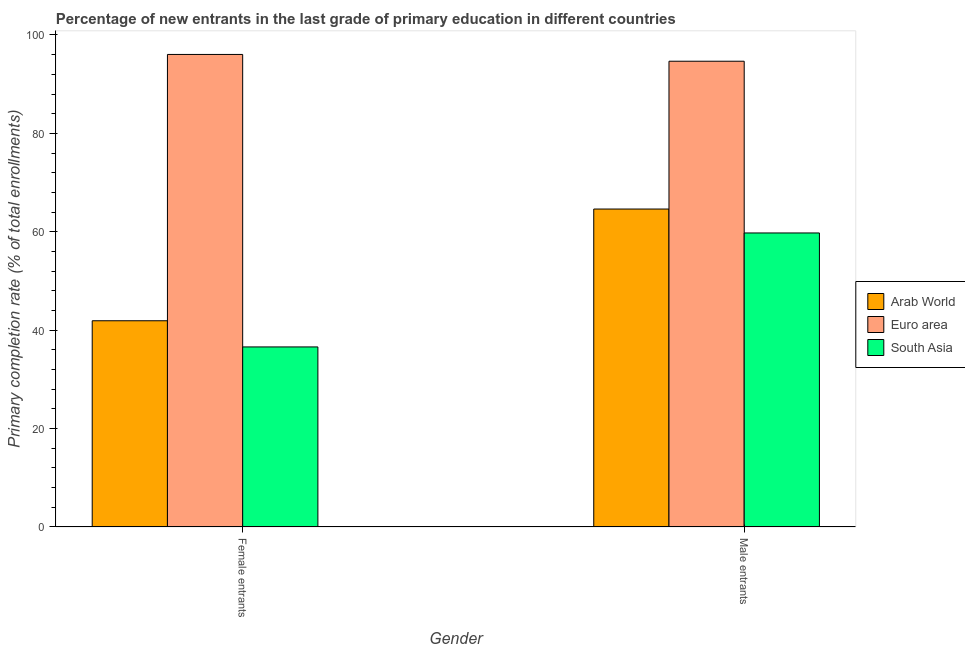How many different coloured bars are there?
Your answer should be compact. 3. Are the number of bars on each tick of the X-axis equal?
Offer a very short reply. Yes. How many bars are there on the 1st tick from the right?
Your response must be concise. 3. What is the label of the 2nd group of bars from the left?
Give a very brief answer. Male entrants. What is the primary completion rate of male entrants in South Asia?
Make the answer very short. 59.76. Across all countries, what is the maximum primary completion rate of male entrants?
Offer a very short reply. 94.66. Across all countries, what is the minimum primary completion rate of male entrants?
Provide a succinct answer. 59.76. What is the total primary completion rate of female entrants in the graph?
Make the answer very short. 174.55. What is the difference between the primary completion rate of male entrants in Arab World and that in South Asia?
Offer a very short reply. 4.86. What is the difference between the primary completion rate of male entrants in South Asia and the primary completion rate of female entrants in Euro area?
Offer a very short reply. -36.28. What is the average primary completion rate of male entrants per country?
Ensure brevity in your answer.  73.01. What is the difference between the primary completion rate of female entrants and primary completion rate of male entrants in South Asia?
Provide a succinct answer. -23.16. What is the ratio of the primary completion rate of female entrants in Arab World to that in South Asia?
Keep it short and to the point. 1.15. What does the 1st bar from the left in Male entrants represents?
Make the answer very short. Arab World. What does the 2nd bar from the right in Male entrants represents?
Keep it short and to the point. Euro area. How many countries are there in the graph?
Provide a short and direct response. 3. Does the graph contain any zero values?
Ensure brevity in your answer.  No. Does the graph contain grids?
Your answer should be compact. No. How many legend labels are there?
Give a very brief answer. 3. How are the legend labels stacked?
Give a very brief answer. Vertical. What is the title of the graph?
Keep it short and to the point. Percentage of new entrants in the last grade of primary education in different countries. What is the label or title of the Y-axis?
Offer a terse response. Primary completion rate (% of total enrollments). What is the Primary completion rate (% of total enrollments) of Arab World in Female entrants?
Make the answer very short. 41.92. What is the Primary completion rate (% of total enrollments) in Euro area in Female entrants?
Provide a short and direct response. 96.04. What is the Primary completion rate (% of total enrollments) in South Asia in Female entrants?
Offer a terse response. 36.6. What is the Primary completion rate (% of total enrollments) of Arab World in Male entrants?
Keep it short and to the point. 64.62. What is the Primary completion rate (% of total enrollments) of Euro area in Male entrants?
Your answer should be very brief. 94.66. What is the Primary completion rate (% of total enrollments) of South Asia in Male entrants?
Offer a very short reply. 59.76. Across all Gender, what is the maximum Primary completion rate (% of total enrollments) in Arab World?
Offer a very short reply. 64.62. Across all Gender, what is the maximum Primary completion rate (% of total enrollments) in Euro area?
Ensure brevity in your answer.  96.04. Across all Gender, what is the maximum Primary completion rate (% of total enrollments) of South Asia?
Offer a terse response. 59.76. Across all Gender, what is the minimum Primary completion rate (% of total enrollments) in Arab World?
Provide a short and direct response. 41.92. Across all Gender, what is the minimum Primary completion rate (% of total enrollments) of Euro area?
Offer a very short reply. 94.66. Across all Gender, what is the minimum Primary completion rate (% of total enrollments) of South Asia?
Provide a short and direct response. 36.6. What is the total Primary completion rate (% of total enrollments) of Arab World in the graph?
Offer a very short reply. 106.54. What is the total Primary completion rate (% of total enrollments) in Euro area in the graph?
Give a very brief answer. 190.7. What is the total Primary completion rate (% of total enrollments) of South Asia in the graph?
Provide a short and direct response. 96.35. What is the difference between the Primary completion rate (% of total enrollments) in Arab World in Female entrants and that in Male entrants?
Ensure brevity in your answer.  -22.7. What is the difference between the Primary completion rate (% of total enrollments) of Euro area in Female entrants and that in Male entrants?
Your answer should be compact. 1.38. What is the difference between the Primary completion rate (% of total enrollments) of South Asia in Female entrants and that in Male entrants?
Your answer should be compact. -23.16. What is the difference between the Primary completion rate (% of total enrollments) in Arab World in Female entrants and the Primary completion rate (% of total enrollments) in Euro area in Male entrants?
Offer a terse response. -52.74. What is the difference between the Primary completion rate (% of total enrollments) of Arab World in Female entrants and the Primary completion rate (% of total enrollments) of South Asia in Male entrants?
Give a very brief answer. -17.84. What is the difference between the Primary completion rate (% of total enrollments) of Euro area in Female entrants and the Primary completion rate (% of total enrollments) of South Asia in Male entrants?
Ensure brevity in your answer.  36.28. What is the average Primary completion rate (% of total enrollments) of Arab World per Gender?
Offer a terse response. 53.27. What is the average Primary completion rate (% of total enrollments) in Euro area per Gender?
Give a very brief answer. 95.35. What is the average Primary completion rate (% of total enrollments) of South Asia per Gender?
Ensure brevity in your answer.  48.18. What is the difference between the Primary completion rate (% of total enrollments) of Arab World and Primary completion rate (% of total enrollments) of Euro area in Female entrants?
Provide a short and direct response. -54.12. What is the difference between the Primary completion rate (% of total enrollments) in Arab World and Primary completion rate (% of total enrollments) in South Asia in Female entrants?
Provide a short and direct response. 5.32. What is the difference between the Primary completion rate (% of total enrollments) of Euro area and Primary completion rate (% of total enrollments) of South Asia in Female entrants?
Keep it short and to the point. 59.44. What is the difference between the Primary completion rate (% of total enrollments) in Arab World and Primary completion rate (% of total enrollments) in Euro area in Male entrants?
Offer a terse response. -30.04. What is the difference between the Primary completion rate (% of total enrollments) in Arab World and Primary completion rate (% of total enrollments) in South Asia in Male entrants?
Offer a terse response. 4.86. What is the difference between the Primary completion rate (% of total enrollments) in Euro area and Primary completion rate (% of total enrollments) in South Asia in Male entrants?
Offer a terse response. 34.9. What is the ratio of the Primary completion rate (% of total enrollments) of Arab World in Female entrants to that in Male entrants?
Your response must be concise. 0.65. What is the ratio of the Primary completion rate (% of total enrollments) in Euro area in Female entrants to that in Male entrants?
Your answer should be very brief. 1.01. What is the ratio of the Primary completion rate (% of total enrollments) in South Asia in Female entrants to that in Male entrants?
Give a very brief answer. 0.61. What is the difference between the highest and the second highest Primary completion rate (% of total enrollments) in Arab World?
Provide a succinct answer. 22.7. What is the difference between the highest and the second highest Primary completion rate (% of total enrollments) of Euro area?
Offer a terse response. 1.38. What is the difference between the highest and the second highest Primary completion rate (% of total enrollments) in South Asia?
Your answer should be very brief. 23.16. What is the difference between the highest and the lowest Primary completion rate (% of total enrollments) in Arab World?
Offer a terse response. 22.7. What is the difference between the highest and the lowest Primary completion rate (% of total enrollments) of Euro area?
Your answer should be compact. 1.38. What is the difference between the highest and the lowest Primary completion rate (% of total enrollments) in South Asia?
Make the answer very short. 23.16. 